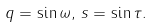<formula> <loc_0><loc_0><loc_500><loc_500>q = \sin { \omega } , \, s = \sin { \tau } .</formula> 